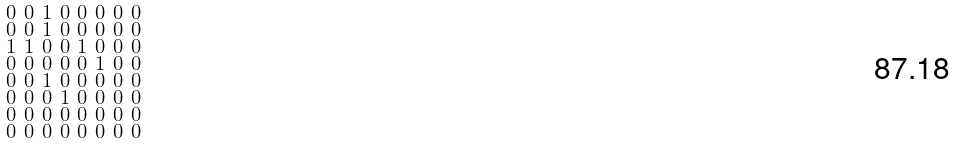<formula> <loc_0><loc_0><loc_500><loc_500>\begin{smallmatrix} 0 & 0 & 1 & 0 & 0 & 0 & 0 & 0 \\ 0 & 0 & 1 & 0 & 0 & 0 & 0 & 0 \\ 1 & 1 & 0 & 0 & 1 & 0 & 0 & 0 \\ 0 & 0 & 0 & 0 & 0 & 1 & 0 & 0 \\ 0 & 0 & 1 & 0 & 0 & 0 & 0 & 0 \\ 0 & 0 & 0 & 1 & 0 & 0 & 0 & 0 \\ 0 & 0 & 0 & 0 & 0 & 0 & 0 & 0 \\ 0 & 0 & 0 & 0 & 0 & 0 & 0 & 0 \end{smallmatrix}</formula> 